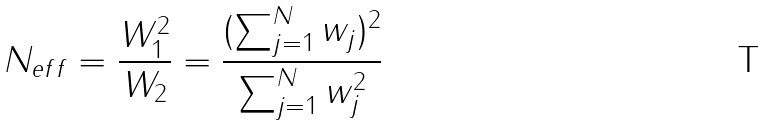Convert formula to latex. <formula><loc_0><loc_0><loc_500><loc_500>N _ { e f f } = \frac { W _ { 1 } ^ { 2 } } { W _ { 2 } } = \frac { ( \sum _ { j = 1 } ^ { N } w _ { j } ) ^ { 2 } } { \sum _ { j = 1 } ^ { N } w _ { j } ^ { 2 } }</formula> 